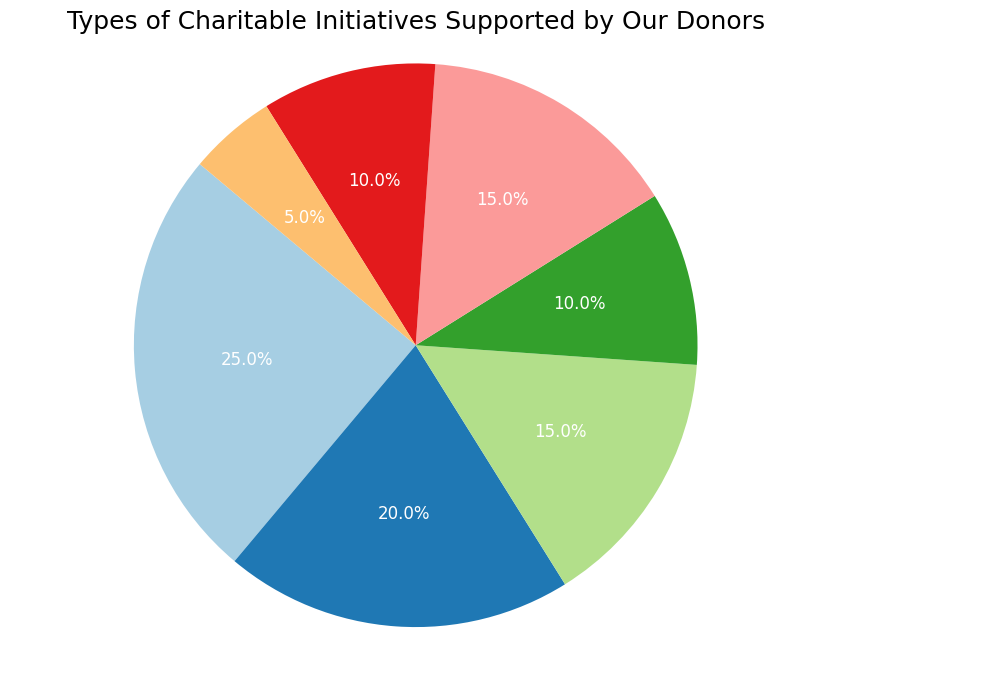Which category has the highest percentage in the pie chart? By looking at the segments in the pie chart, the largest slice corresponds to Education with 25%.
Answer: Education What is the total percentage of categories related to Healthcare and Community Development combined? The pie chart shows Healthcare at 20% and Community Development at 15%. Adding these percentages together gives 20% + 15% = 35%.
Answer: 35% How does the percentage of Environmental Sustainability compare to that of Emergency Relief? The chart indicates that both Environmental Sustainability and Emergency Relief have an equal share, each contributing 10% to the total.
Answer: They are equal Which category has the smallest percentage contribution? Observing the pie chart, the smallest slice belongs to Youth Programs at 5%.
Answer: Youth Programs What is the combined percentage of Education, Healthcare, and Arts and Culture? From the chart, Education is 25%, Healthcare is 20%, and Arts and Culture is 15%. Summing these gives 25% + 20% + 15% = 60%.
Answer: 60% Which category is twice as much as Youth Programs? Checking the pie chart, Youth Programs is 5%. The category that is twice this percentage (10%) is both Environmental Sustainability and Emergency Relief.
Answer: Environmental Sustainability and Emergency Relief Is the proportion of Community Development greater than or equal to that of Arts and Culture? The pie chart illustrates that Community Development and Arts and Culture each have a 15% share. Hence, Community Development is equal to Arts and Culture.
Answer: Equal What is the difference in percentage between the largest and the smallest category? The largest category is Education at 25% and the smallest is Youth Programs at 5%. The difference is 25% - 5% = 20%.
Answer: 20% Which color represents Healthcare and how is its percentage visually conveyed? In the pie chart, Healthcare is represented by its distinct color, identified typically by its position and the legend associated with it. It takes 20% of the chart visually.
Answer: Specific color by legend, 20% What is the average percentage of Emergency Relief and Environmental Sustainability? Both have 10%, and their combined total is 20%. The average is thus 20% / 2 = 10%.
Answer: 10% 